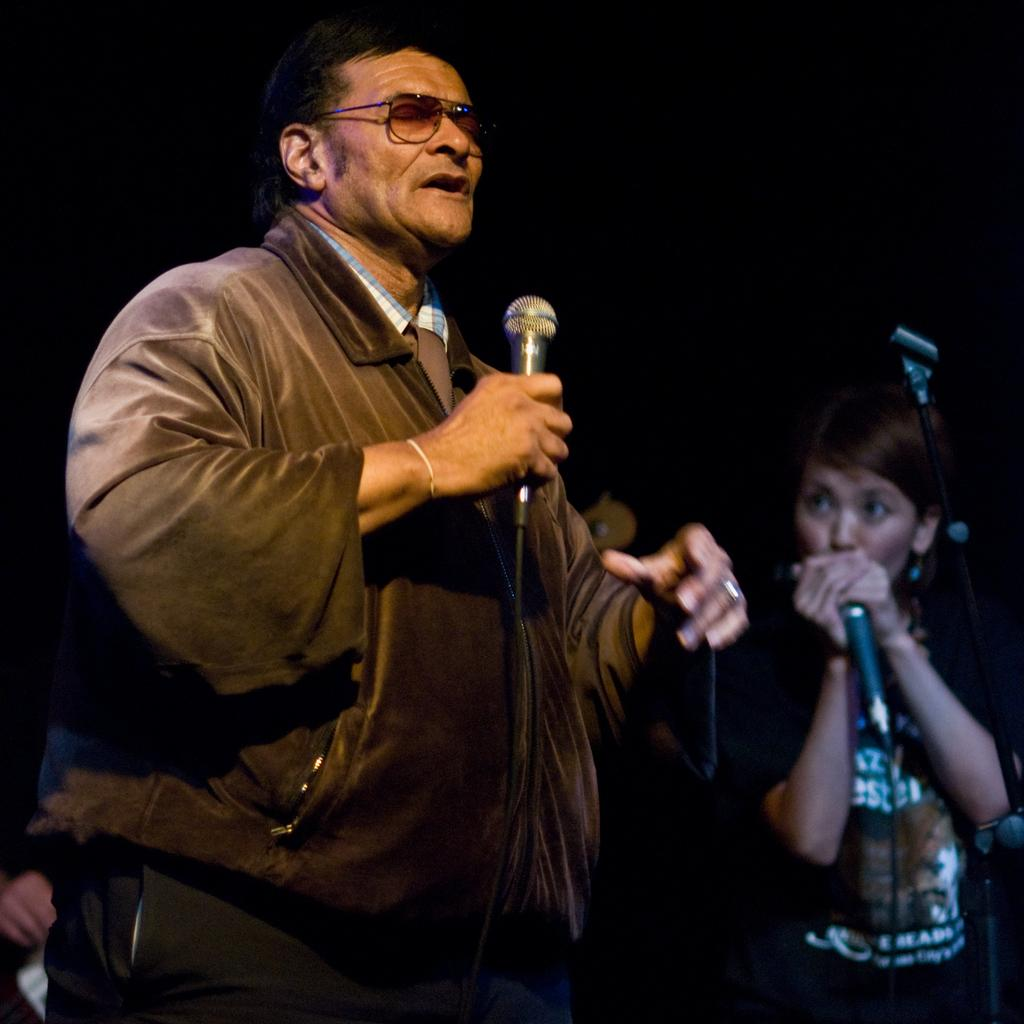How many people are in the image? There are two people in the image. What are the people doing in the image? The people are standing and holding microphones. What is in front of the people? There is a stand in front of the people. What can be observed about the background of the image? The background of the image is dark. What type of advertisement is displayed on the stand in the image? There is no advertisement present on the stand in the image; it is a stand without any visible content. 